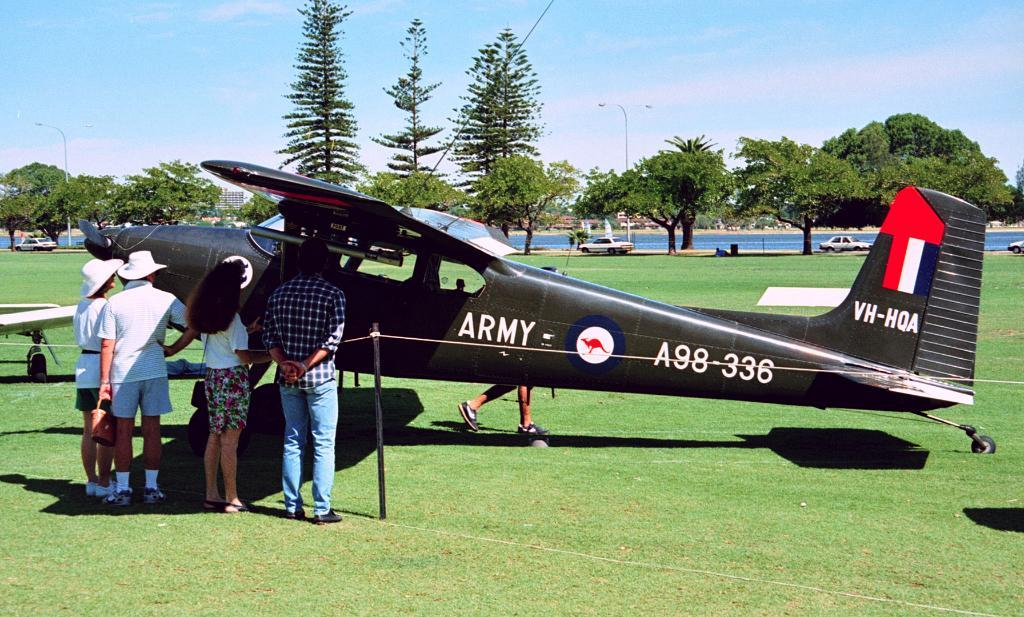<image>
Summarize the visual content of the image. People are standing in front of black propeller plane with "Army " sign on it's side. 